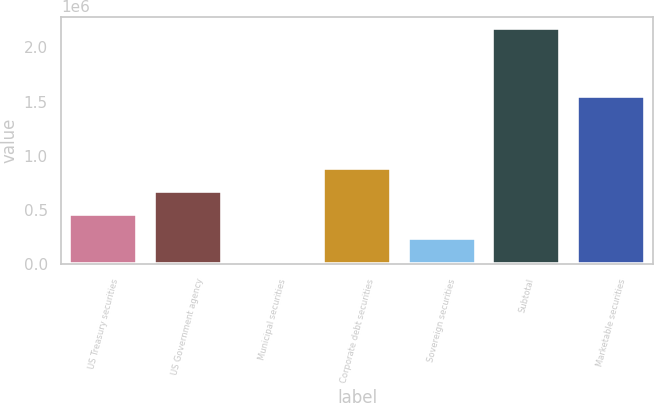Convert chart to OTSL. <chart><loc_0><loc_0><loc_500><loc_500><bar_chart><fcel>US Treasury securities<fcel>US Government agency<fcel>Municipal securities<fcel>Corporate debt securities<fcel>Sovereign securities<fcel>Subtotal<fcel>Marketable securities<nl><fcel>460268<fcel>674495<fcel>31816<fcel>888721<fcel>246042<fcel>2.17408e+06<fcel>1.54909e+06<nl></chart> 